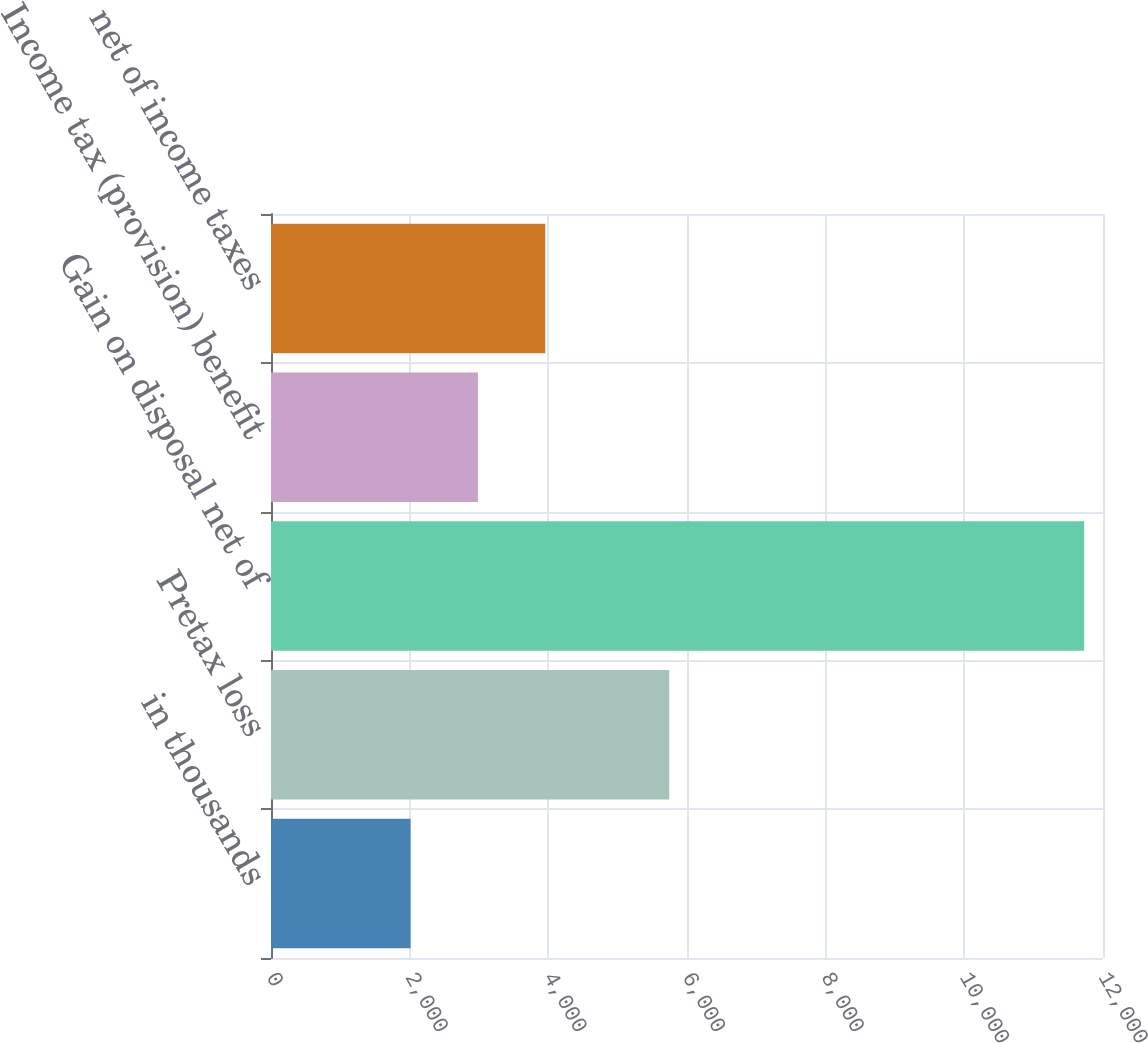Convert chart. <chart><loc_0><loc_0><loc_500><loc_500><bar_chart><fcel>in thousands<fcel>Pretax loss<fcel>Gain on disposal net of<fcel>Income tax (provision) benefit<fcel>net of income taxes<nl><fcel>2013<fcel>5744<fcel>11728<fcel>2984.5<fcel>3956<nl></chart> 